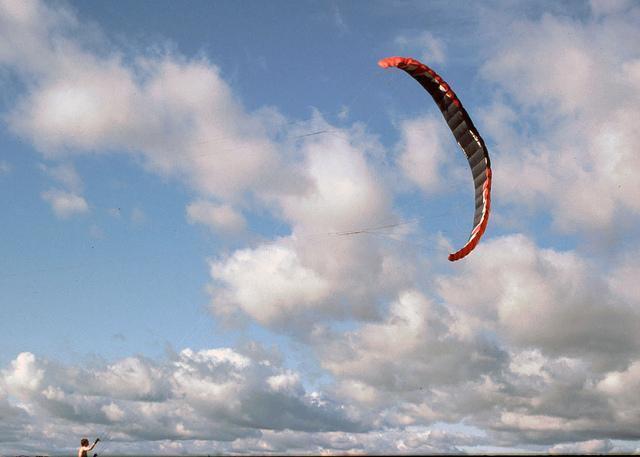How many bears are in the chair?
Give a very brief answer. 0. 